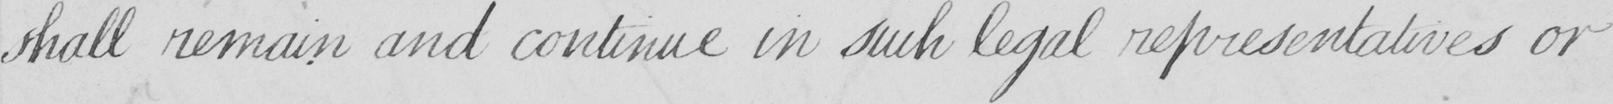What text is written in this handwritten line? shall remain and continue in such legal representatives or 